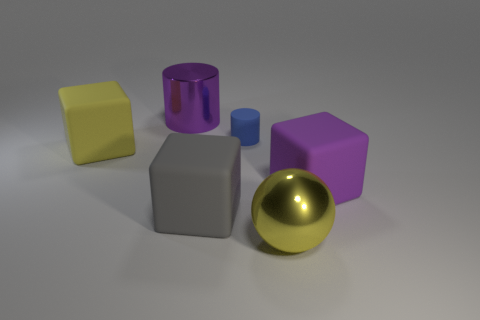Is the tiny blue cylinder made of the same material as the yellow ball?
Provide a short and direct response. No. There is a thing that is in front of the small blue matte object and left of the gray object; what is its size?
Provide a short and direct response. Large. What shape is the gray rubber object?
Offer a very short reply. Cube. How many objects are either yellow objects or big rubber things to the left of the large shiny cylinder?
Give a very brief answer. 2. Is the color of the matte cube that is in front of the large purple rubber cube the same as the tiny rubber cylinder?
Keep it short and to the point. No. There is a large thing that is both behind the large gray object and right of the gray matte object; what color is it?
Offer a very short reply. Purple. There is a yellow object that is left of the sphere; what is its material?
Your answer should be compact. Rubber. The gray matte thing has what size?
Offer a very short reply. Large. How many yellow things are either large things or big rubber blocks?
Your answer should be very brief. 2. There is a yellow thing that is on the right side of the big object on the left side of the big purple metal thing; how big is it?
Provide a succinct answer. Large. 